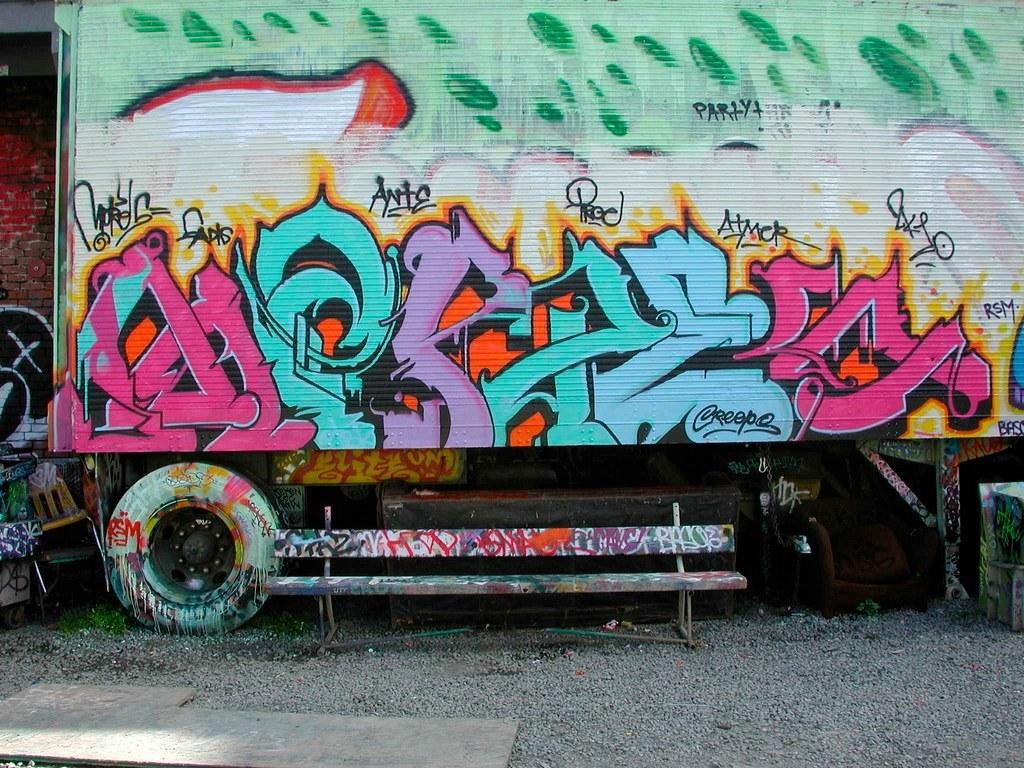What is the main subject of the image? There is a vehicle in the image. What is unique about the vehicle? There is a painting on the vehicle. What can be seen in the background of the image? There is a painting on a wall in the background of the image. What is blocking the view of the wall in the image? There are objects in front of the wall. What color is the ice on the vehicle in the image? There is no ice present in the image; it features a vehicle with a painting on it. How does the grip of the vehicle change throughout the image? The image does not show any changes in the grip of the vehicle, as it is a still image. 